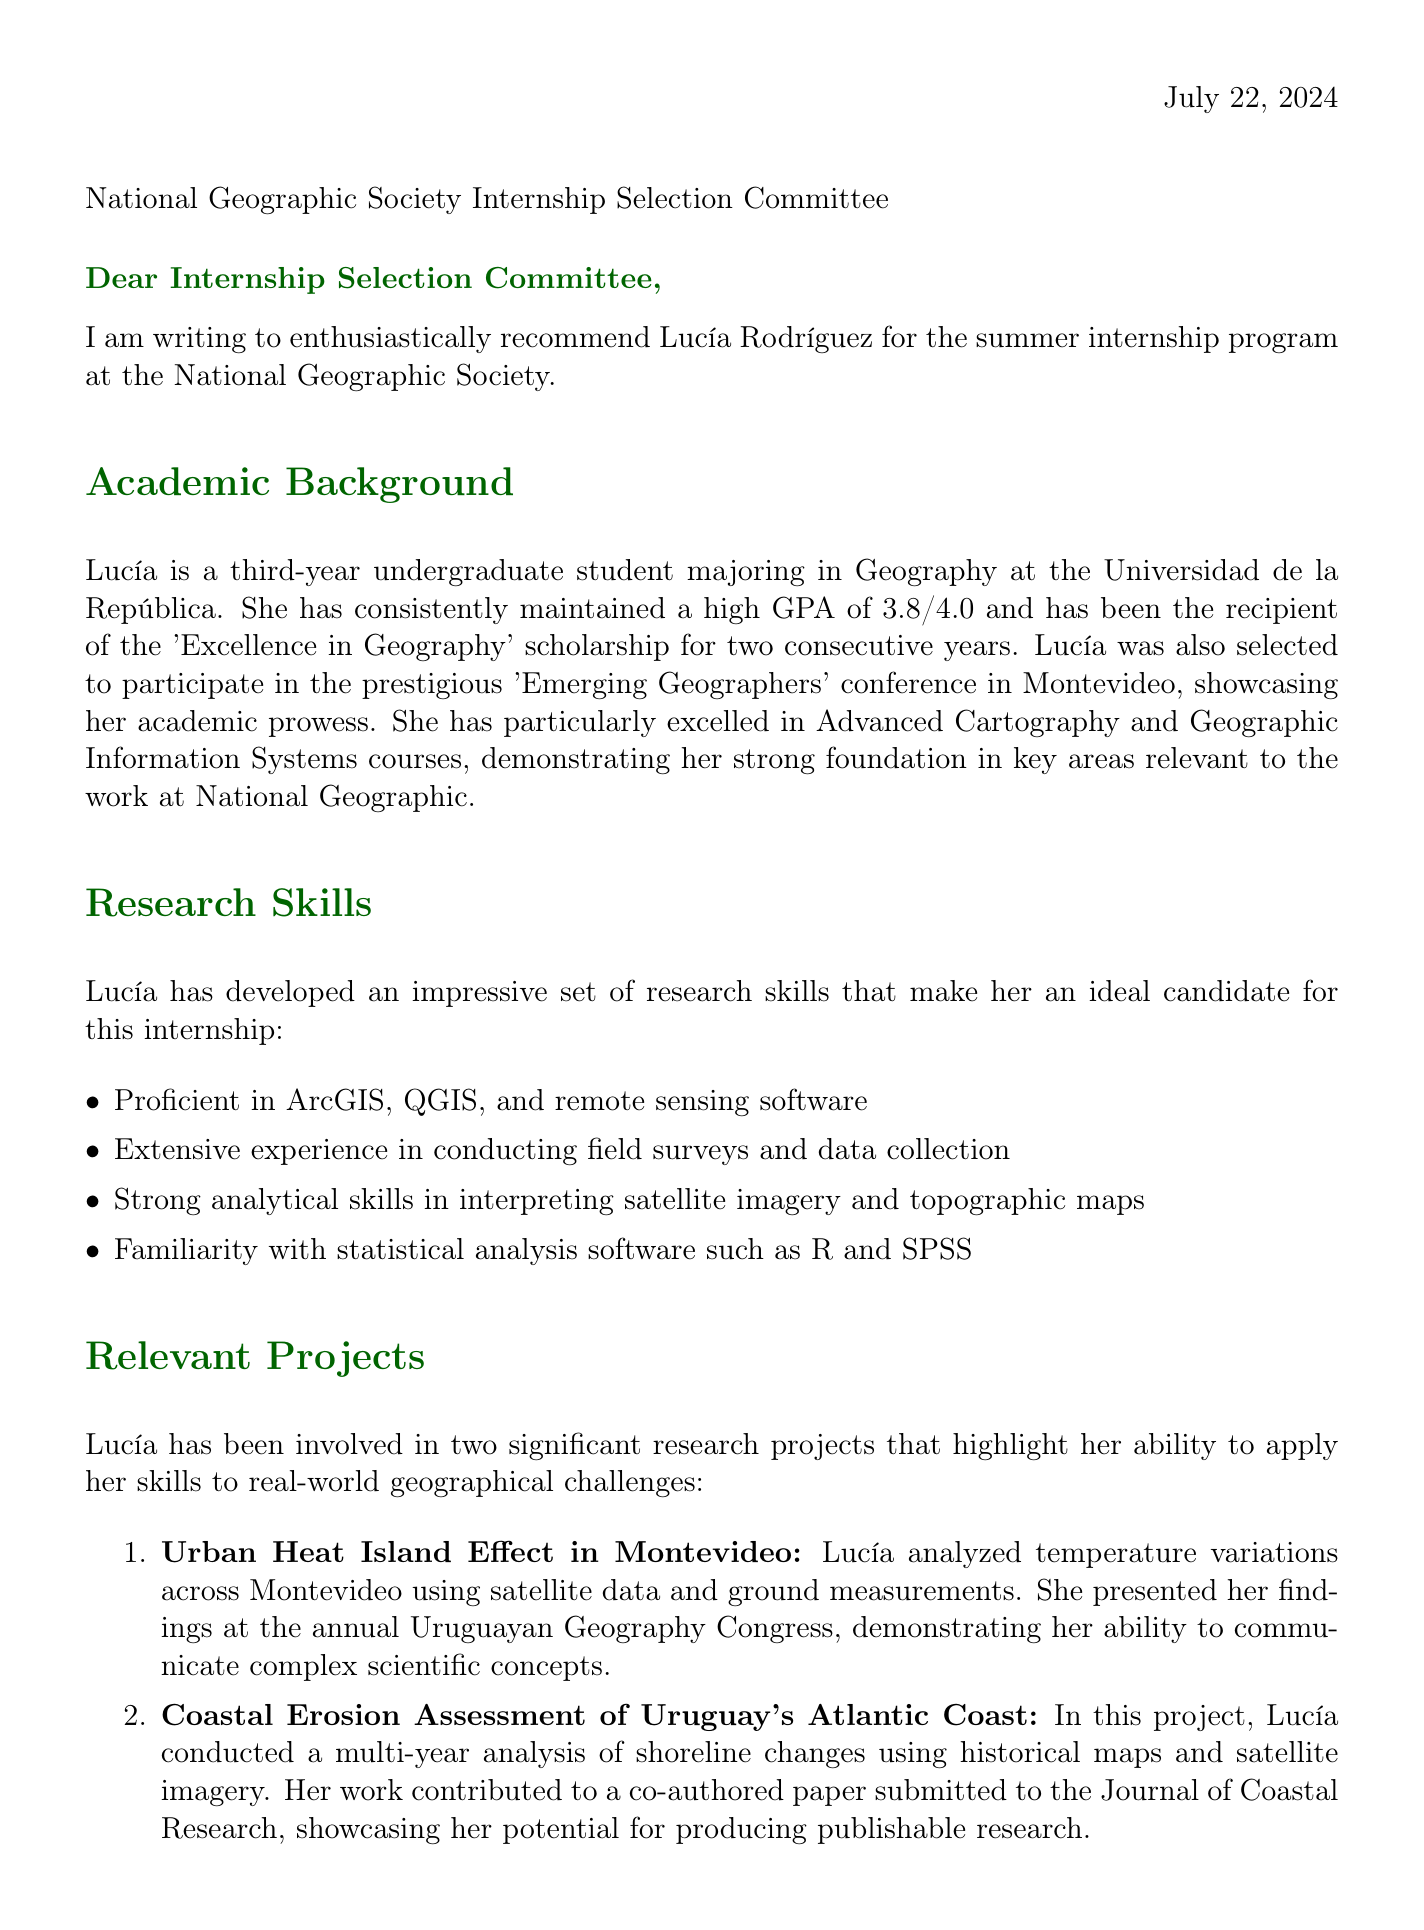What is the name of the student being recommended? The document explicitly mentions the student being recommended for the internship, which is Lucía Rodríguez.
Answer: Lucía Rodríguez Who is the professor providing the recommendation? The letter includes the name of the professor who recommends the student, which is Dr. Gabriela Fernández.
Answer: Dr. Gabriela Fernández What is Lucía's GPA? The document states that Lucía has maintained a GPA of 3.8 out of 4.0.
Answer: 3.8/4.0 In which year of study is Lucía currently? The letter specifies that Lucía is a third-year undergraduate student.
Answer: Third-year undergraduate What is one software program Lucía is proficient in? The document lists several software programs, one of which is ArcGIS.
Answer: ArcGIS What research project did Lucía present at a conference? The letter mentions that Lucía presented her findings on the Urban Heat Island Effect in Montevideo at the annual Uruguayan Geography Congress.
Answer: Urban Heat Island Effect in Montevideo What personal quality is highlighted as exceptional in Lucía? The letter emphasizes Lucía's exceptional problem-solving skills as one of her personal qualities.
Answer: Problem-solving skills What future career interest does Lucía have? The document states that Lucía has a keen interest in pursuing a career in environmental conservation and sustainable development.
Answer: Environmental conservation What is the concluding statement of the professor in the letter? The professor's closing statement emphasizes their wholehearted recommendation for Lucía for the internship.
Answer: I wholeheartedly recommend Lucía Rodríguez for this internship opportunity 